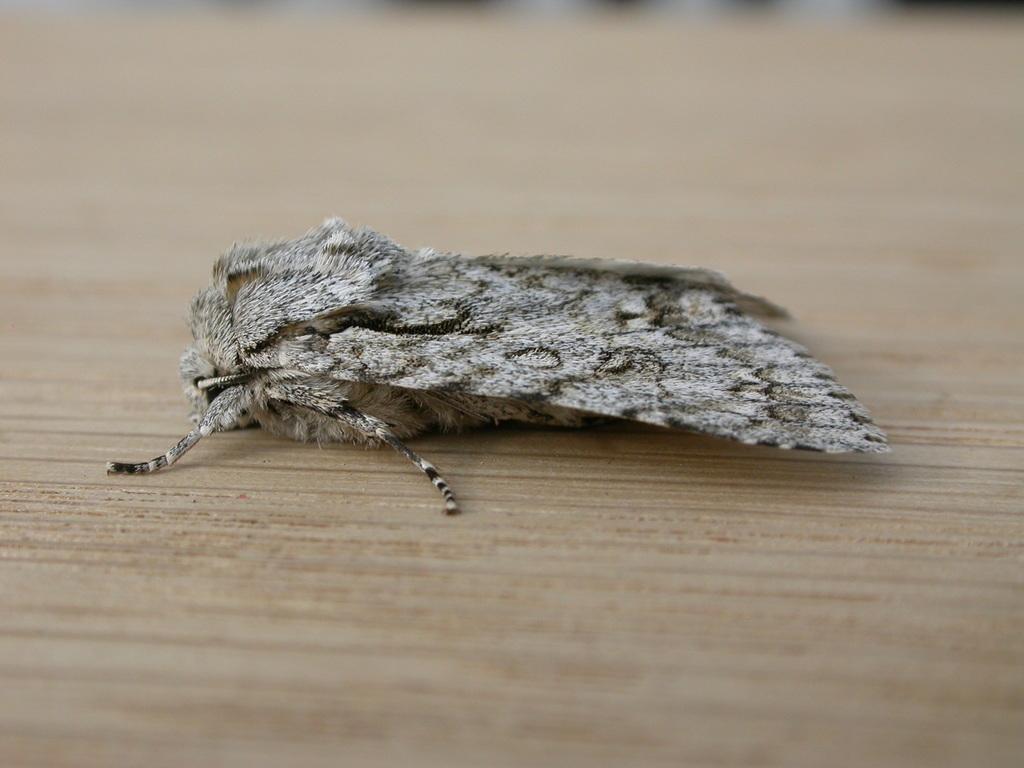Could you give a brief overview of what you see in this image? This picture shows a peppered moth on the table. 